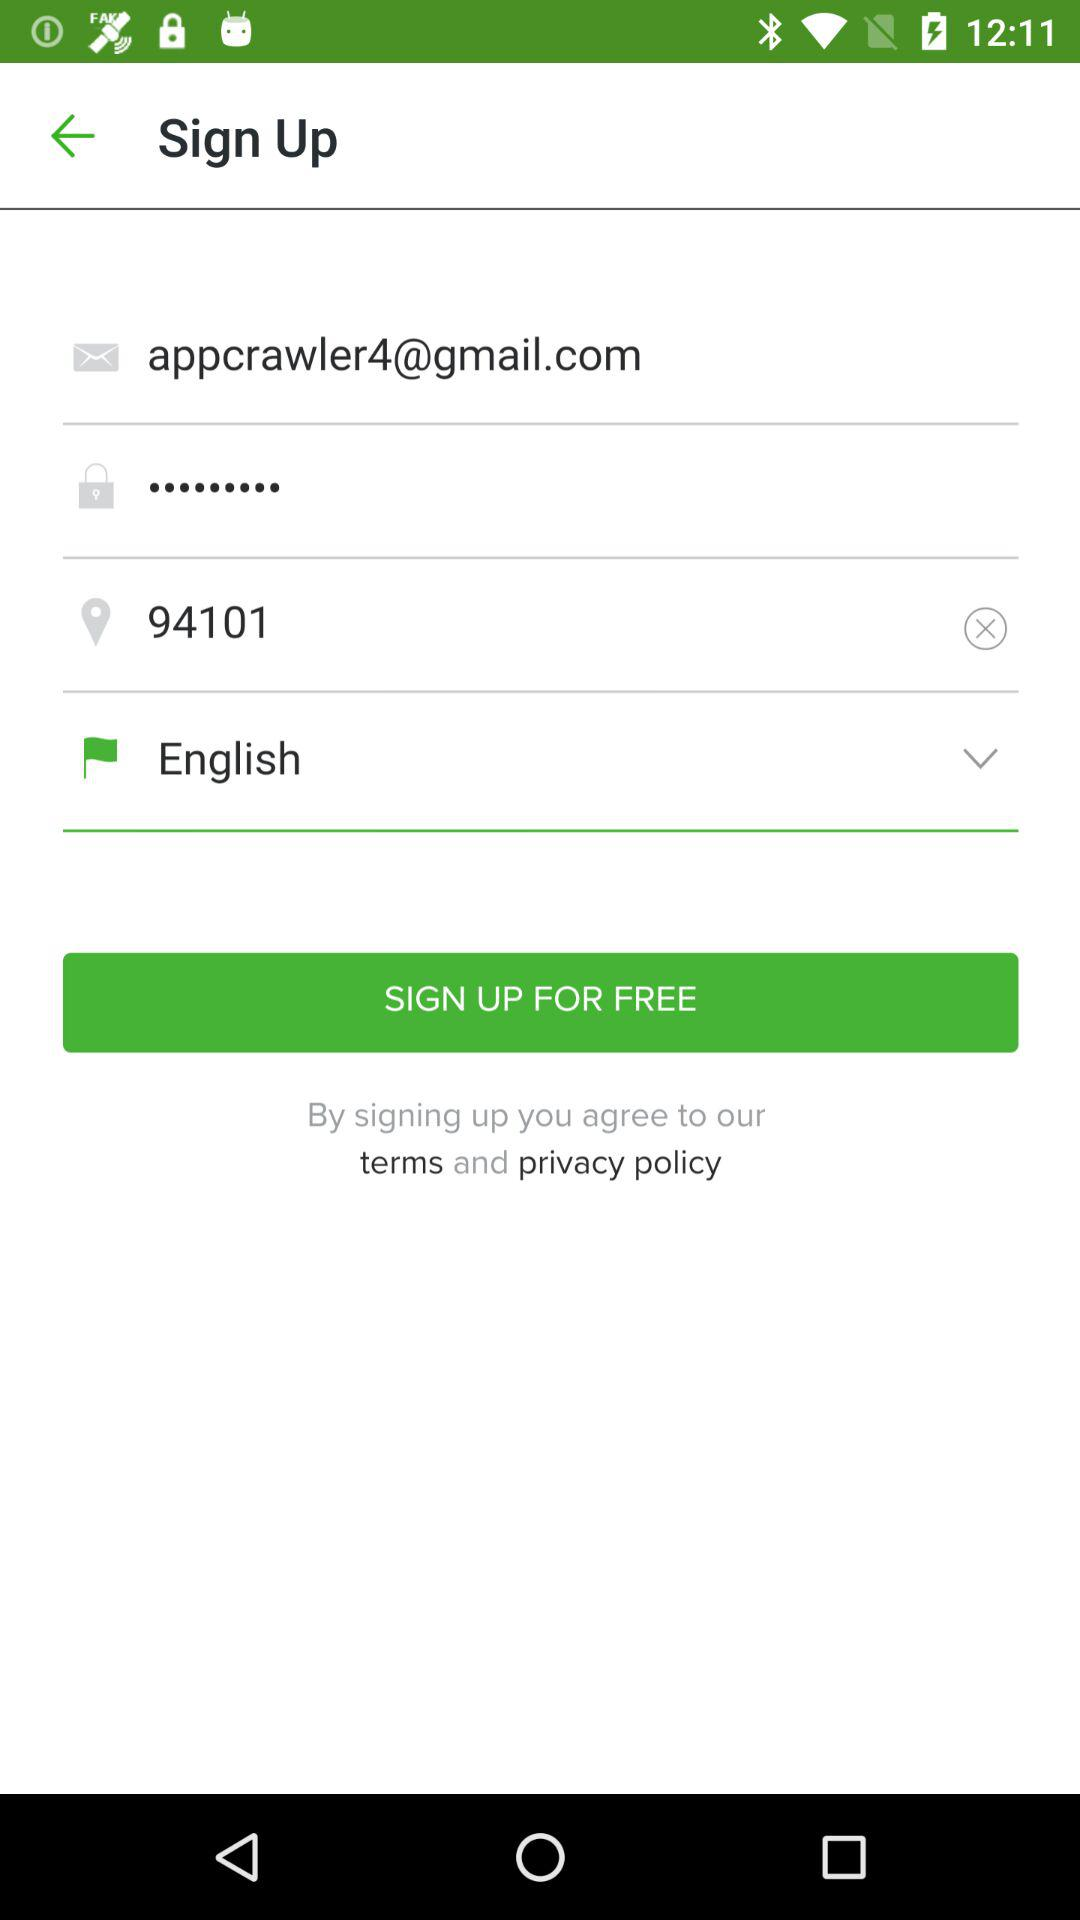What is the pin code? The pin code is 94101. 